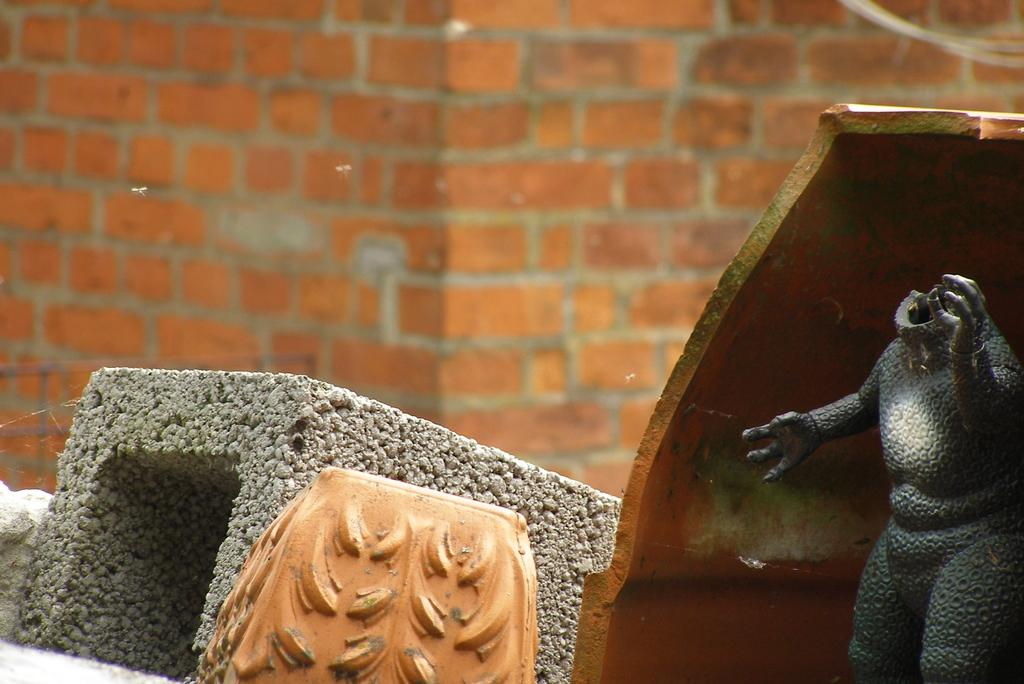What can be seen in the background of the image? There is a big wall in the background of the image. What are the two thin, long objects in the image? There are two wires visible in the image. What type of artwork is present in the image? There is a sculpture in the image. What is on the ground in the image? There are objects on the ground in the image. Can you hear the sculpture cry in the image? There is no sound or indication of crying in the image; it is a visual representation of a sculpture. What type of boundary is depicted in the image? There is no boundary depicted in the image; the focus is on the wall, wires, sculpture, and objects on the ground. 